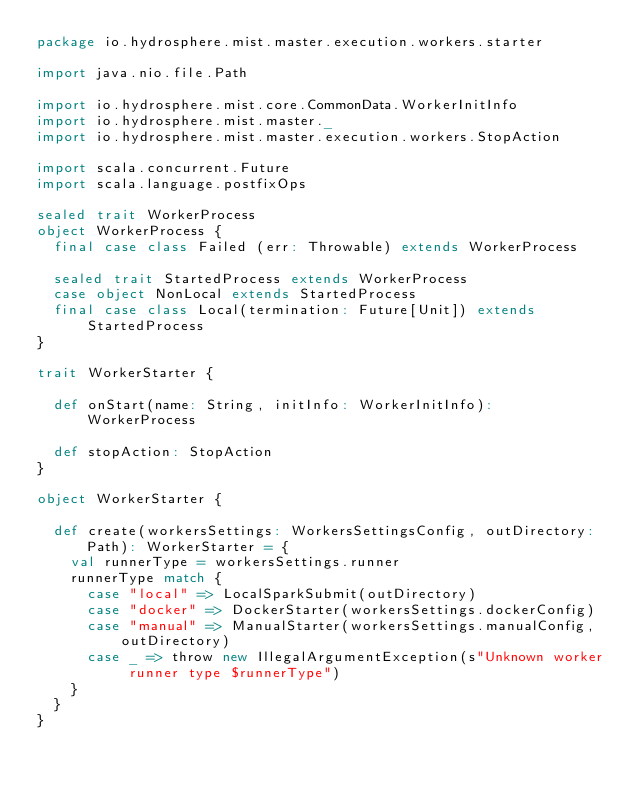Convert code to text. <code><loc_0><loc_0><loc_500><loc_500><_Scala_>package io.hydrosphere.mist.master.execution.workers.starter

import java.nio.file.Path

import io.hydrosphere.mist.core.CommonData.WorkerInitInfo
import io.hydrosphere.mist.master._
import io.hydrosphere.mist.master.execution.workers.StopAction

import scala.concurrent.Future
import scala.language.postfixOps

sealed trait WorkerProcess
object WorkerProcess {
  final case class Failed (err: Throwable) extends WorkerProcess

  sealed trait StartedProcess extends WorkerProcess
  case object NonLocal extends StartedProcess
  final case class Local(termination: Future[Unit]) extends StartedProcess
}

trait WorkerStarter {

  def onStart(name: String, initInfo: WorkerInitInfo): WorkerProcess

  def stopAction: StopAction
}

object WorkerStarter {

  def create(workersSettings: WorkersSettingsConfig, outDirectory: Path): WorkerStarter = {
    val runnerType = workersSettings.runner
    runnerType match {
      case "local" => LocalSparkSubmit(outDirectory)
      case "docker" => DockerStarter(workersSettings.dockerConfig)
      case "manual" => ManualStarter(workersSettings.manualConfig, outDirectory)
      case _ => throw new IllegalArgumentException(s"Unknown worker runner type $runnerType")
    }
  }
}

</code> 